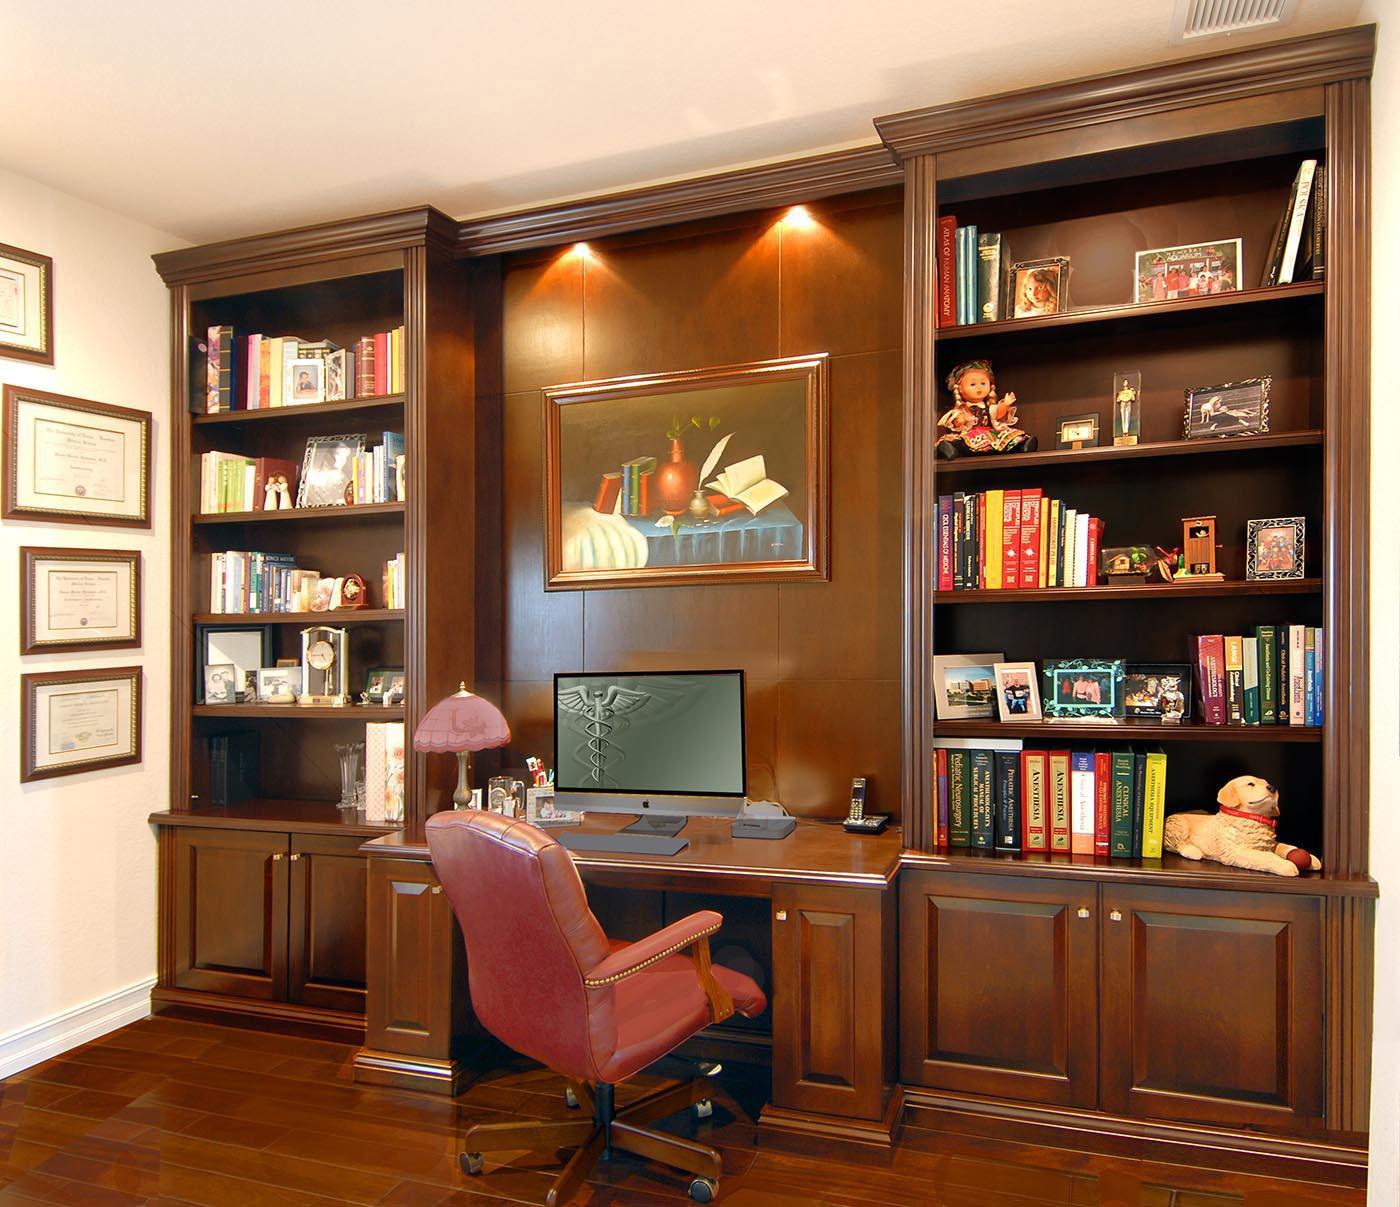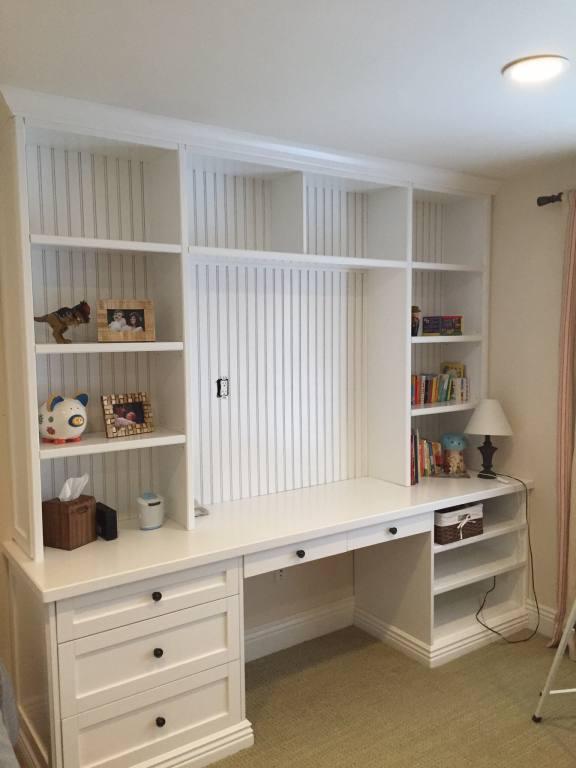The first image is the image on the left, the second image is the image on the right. Given the left and right images, does the statement "An image shows a desk topped with a monitor and coupled with brown shelves for books." hold true? Answer yes or no. Yes. The first image is the image on the left, the second image is the image on the right. For the images displayed, is the sentence "At least two woode chairs are by a computer desk." factually correct? Answer yes or no. No. 